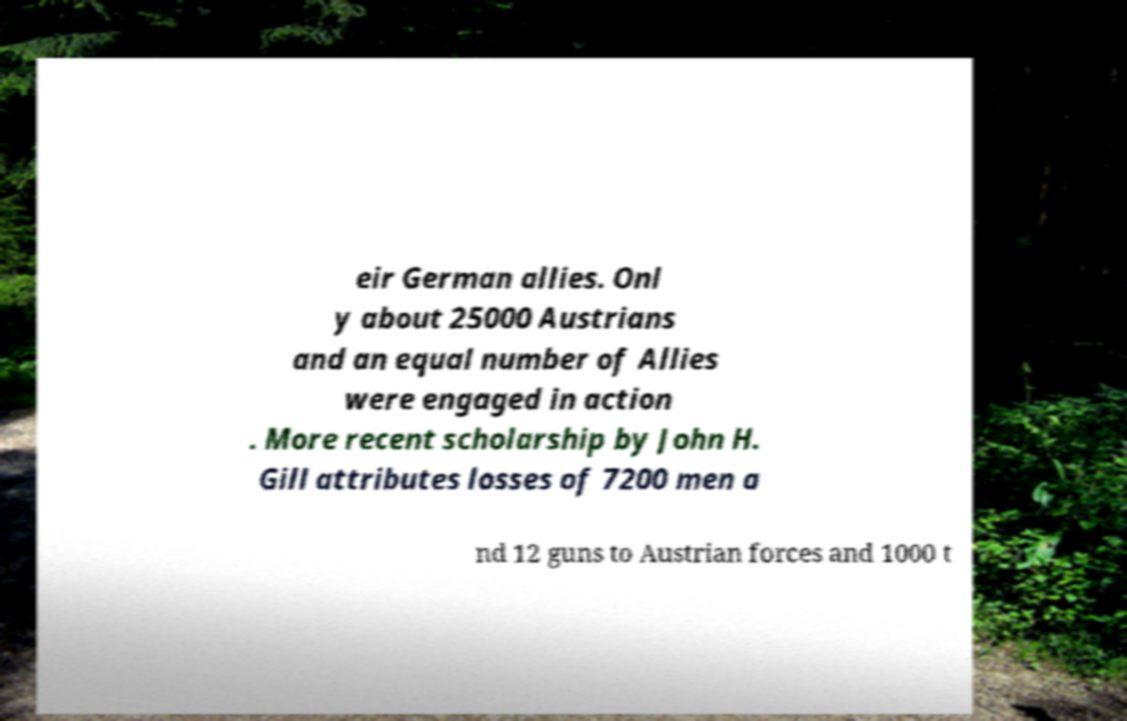Can you accurately transcribe the text from the provided image for me? eir German allies. Onl y about 25000 Austrians and an equal number of Allies were engaged in action . More recent scholarship by John H. Gill attributes losses of 7200 men a nd 12 guns to Austrian forces and 1000 t 